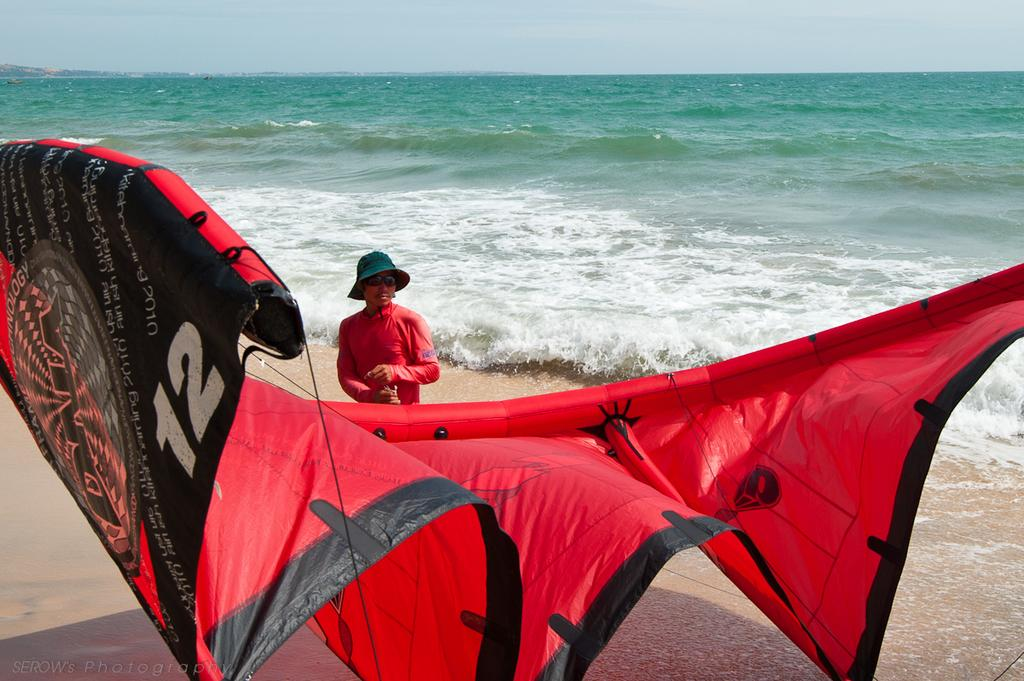Who is present in the image? There is a guy in the image. What is the guy holding in his hand? The guy is holding a red parachute in his hand. What can be seen in the background of the image? There is an ocean in the background of the image. How many women are present in the image? There are no women present in the image; it only features a guy. What type of frogs can be seen swimming in the ocean in the image? There are no frogs present in the image; the background features an ocean, but no animals are visible. 